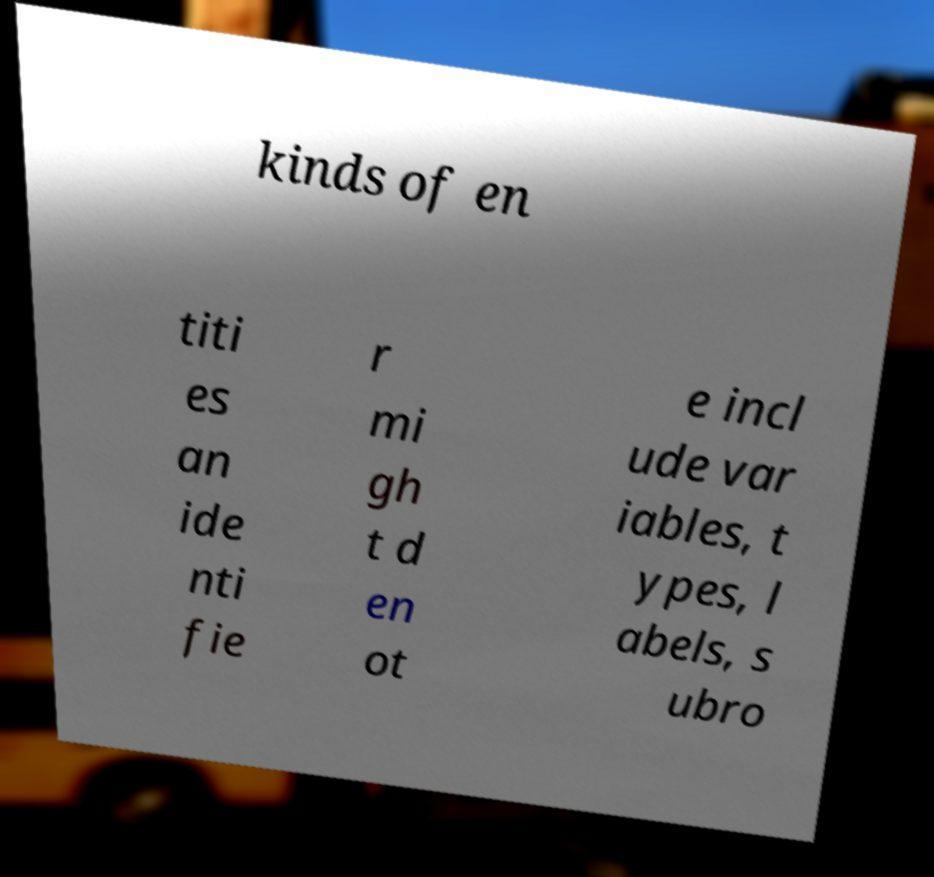What messages or text are displayed in this image? I need them in a readable, typed format. kinds of en titi es an ide nti fie r mi gh t d en ot e incl ude var iables, t ypes, l abels, s ubro 